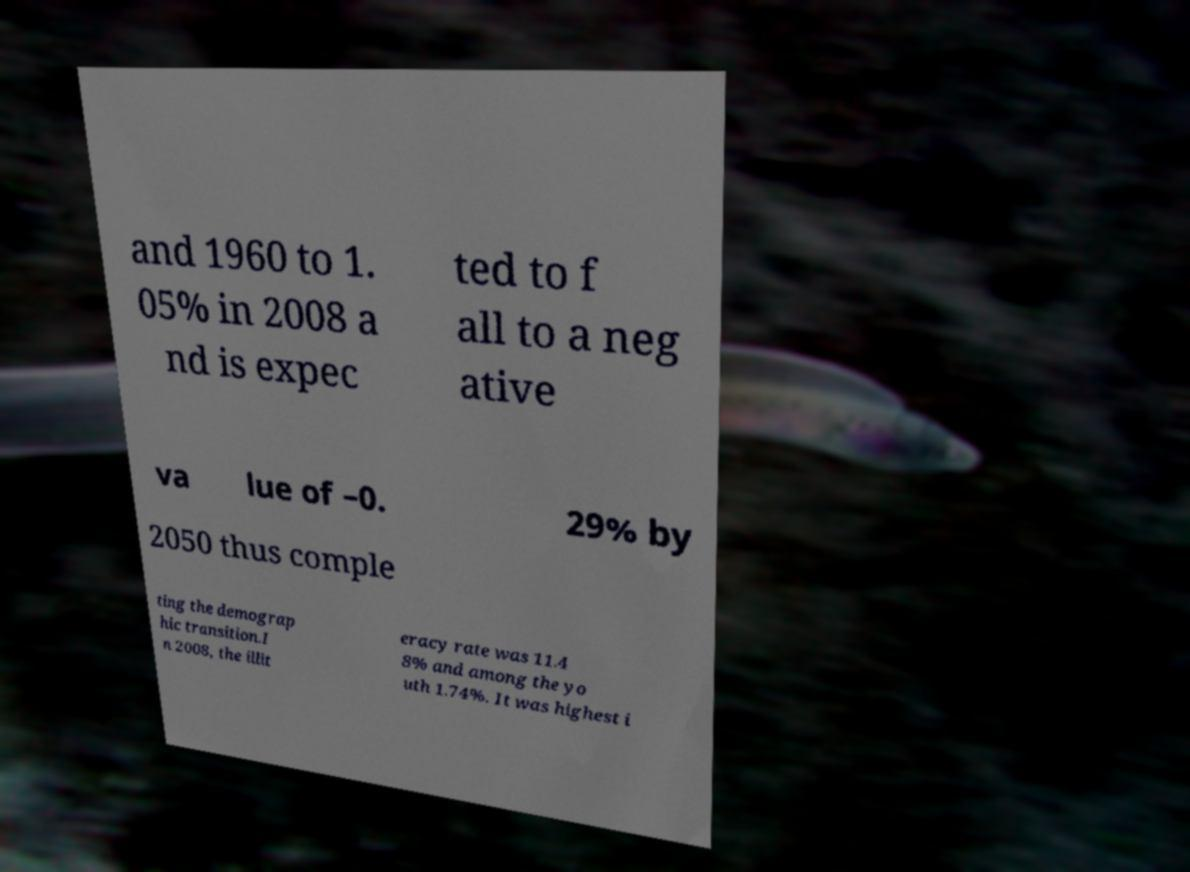Could you assist in decoding the text presented in this image and type it out clearly? and 1960 to 1. 05% in 2008 a nd is expec ted to f all to a neg ative va lue of –0. 29% by 2050 thus comple ting the demograp hic transition.I n 2008, the illit eracy rate was 11.4 8% and among the yo uth 1.74%. It was highest i 